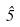Convert formula to latex. <formula><loc_0><loc_0><loc_500><loc_500>\hat { 5 }</formula> 